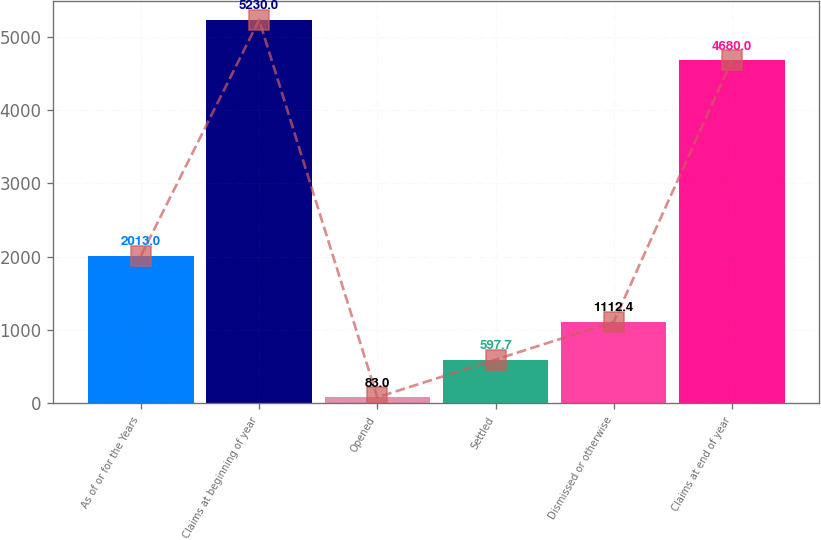Convert chart. <chart><loc_0><loc_0><loc_500><loc_500><bar_chart><fcel>As of or for the Years<fcel>Claims at beginning of year<fcel>Opened<fcel>Settled<fcel>Dismissed or otherwise<fcel>Claims at end of year<nl><fcel>2013<fcel>5230<fcel>83<fcel>597.7<fcel>1112.4<fcel>4680<nl></chart> 